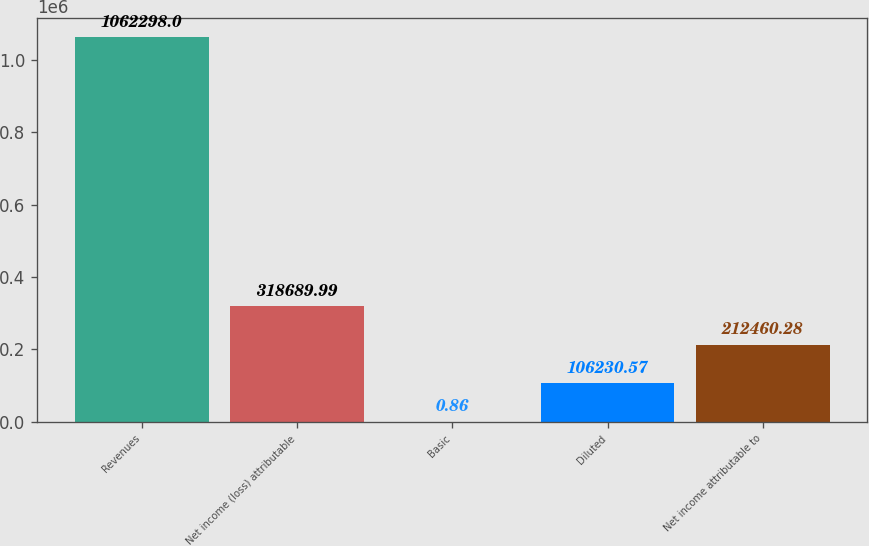<chart> <loc_0><loc_0><loc_500><loc_500><bar_chart><fcel>Revenues<fcel>Net income (loss) attributable<fcel>Basic<fcel>Diluted<fcel>Net income attributable to<nl><fcel>1.0623e+06<fcel>318690<fcel>0.86<fcel>106231<fcel>212460<nl></chart> 